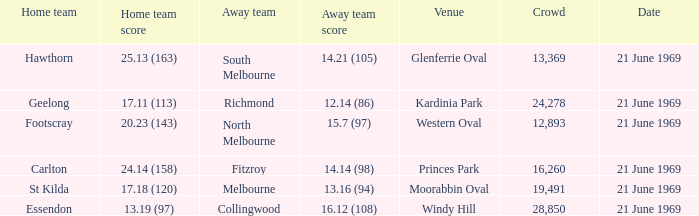When was there a game at Kardinia Park? 21 June 1969. 